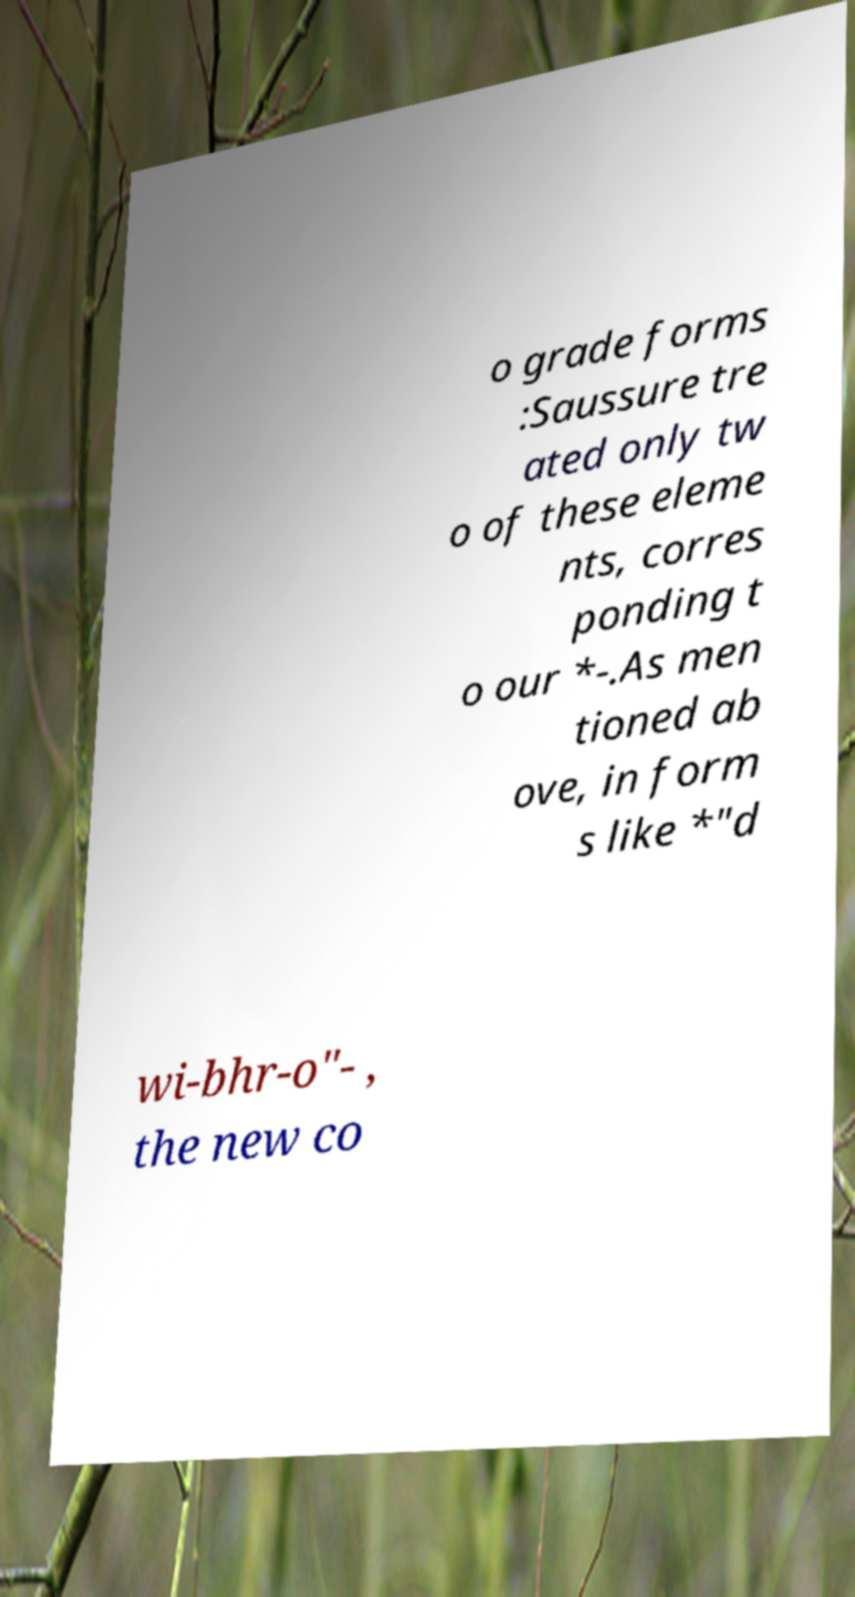Can you read and provide the text displayed in the image?This photo seems to have some interesting text. Can you extract and type it out for me? o grade forms :Saussure tre ated only tw o of these eleme nts, corres ponding t o our *-.As men tioned ab ove, in form s like *"d wi-bhr-o"- , the new co 